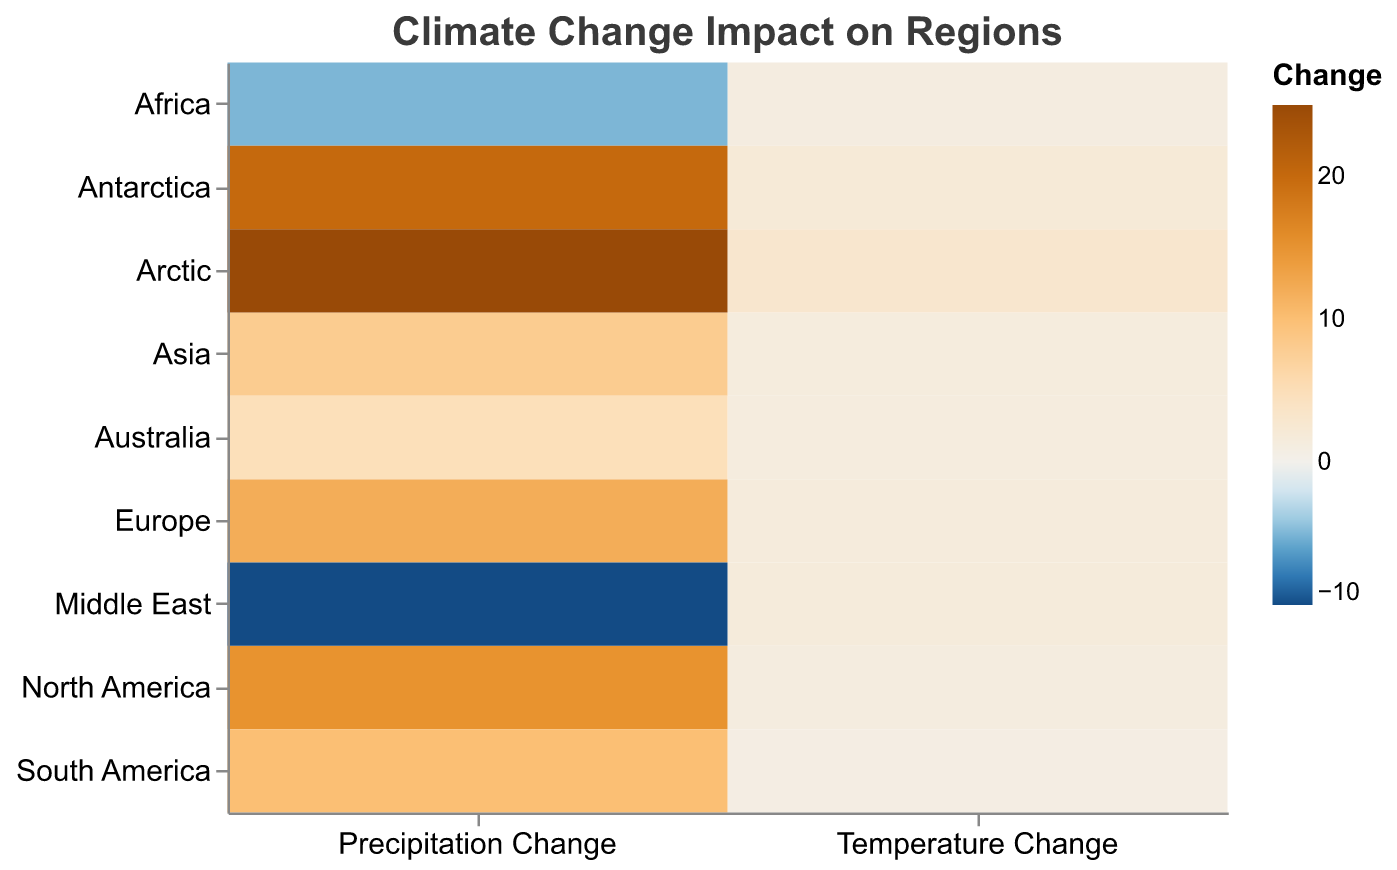What is the title of the heatmap? The title of the heatmap is a text element at the top of the figure, which reads "Climate Change Impact on Regions".
Answer: Climate Change Impact on Regions Which region has the highest temperature change? By looking at the colors representing temperature change across the rows, the Arctic has the highest change with a value of 3.0.
Answer: Arctic How many regions show a negative change in precipitation? Count the number of regions that have a negative value for precipitation change. Africa and the Middle East have negative changes.
Answer: 2 Which region experienced the largest change in precipitation levels? Compare the color intensities of precipitation changes across the regions. The Arctic shows the largest change with a precipitation change of 25.
Answer: Arctic What is the average temperature change across all regions? Sum all the temperature change values and divide by the number of regions (9). Calculation: (1.2 + 0.8 + 1.5 + 1.1 + 1.4 + 1.3 + 2.0 + 1.6 + 3.0) / 9 = 1.54.
Answer: 1.54 Which region has a temperature change closest to 1.5? Compare each region's temperature change value with 1.5. Europe has a temperature change exactly 1.5.
Answer: Europe Which regions have both temperature and precipitation changes above their respective averages? Calculate the average temperature change (1.54) and average precipitation change ((15 + 10 + 12 - 5 + 8 + 5 + 20 - 10 + 25) / 9 = 8.9), then identify regions above both averages: Antarctica and Arctic.
Answer: Antarctica, Arctic What is the total precipitation change for all regions combined? Sum all precipitation change values. Calculation: 15 + 10 + 12 - 5 + 8 + 5 + 20 - 10 + 25 = 80.
Answer: 80 Is there any region with a temperature change below 1.0? Look for regions with values less than 1.0 in the temperature change column. South America has a temperature change of 0.8.
Answer: South America Compare the temperature change between Africa and Australia. Which one experienced a higher change? Check the temperature change values for Africa and Australia. Africa has 1.1 and Australia has 1.3, making Australia's value higher.
Answer: Australia 